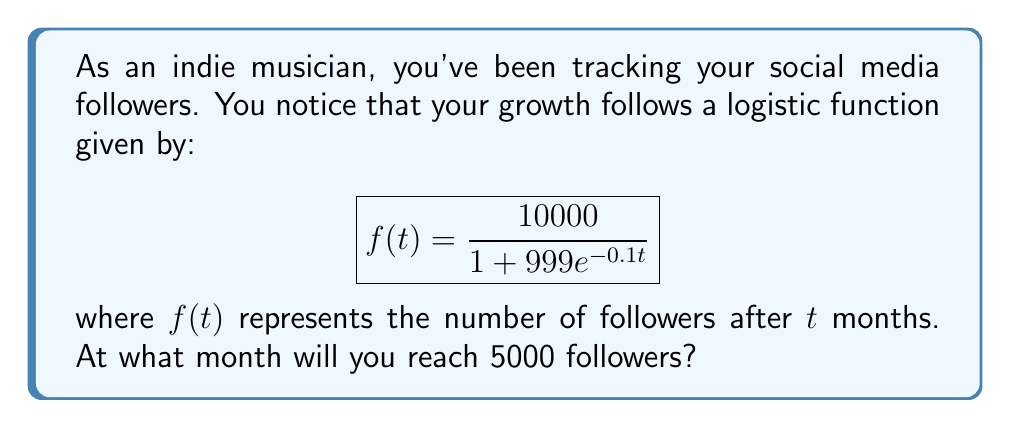Teach me how to tackle this problem. To solve this problem, we need to follow these steps:

1) We want to find $t$ when $f(t) = 5000$. So, let's set up the equation:

   $$5000 = \frac{10000}{1 + 999e^{-0.1t}}$$

2) Multiply both sides by $(1 + 999e^{-0.1t})$:

   $$5000(1 + 999e^{-0.1t}) = 10000$$

3) Divide both sides by 5000:

   $$1 + 999e^{-0.1t} = 2$$

4) Subtract 1 from both sides:

   $$999e^{-0.1t} = 1$$

5) Divide both sides by 999:

   $$e^{-0.1t} = \frac{1}{999}$$

6) Take the natural log of both sides:

   $$-0.1t = \ln(\frac{1}{999}) = -\ln(999)$$

7) Divide both sides by -0.1:

   $$t = \frac{\ln(999)}{0.1}$$

8) Calculate the result:

   $$t \approx 69.08$$

Since we're dealing with months, we need to round up to the nearest whole number.
Answer: 70 months 